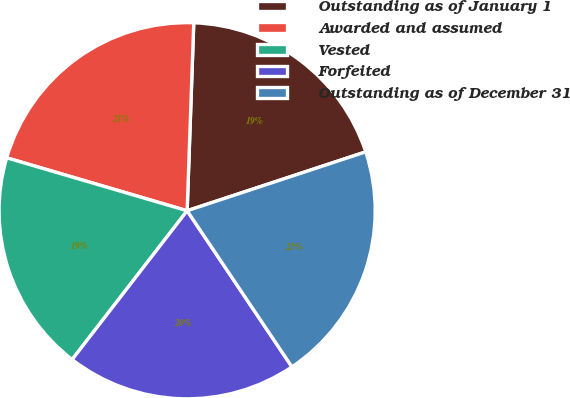<chart> <loc_0><loc_0><loc_500><loc_500><pie_chart><fcel>Outstanding as of January 1<fcel>Awarded and assumed<fcel>Vested<fcel>Forfeited<fcel>Outstanding as of December 31<nl><fcel>19.37%<fcel>21.02%<fcel>19.07%<fcel>19.88%<fcel>20.66%<nl></chart> 